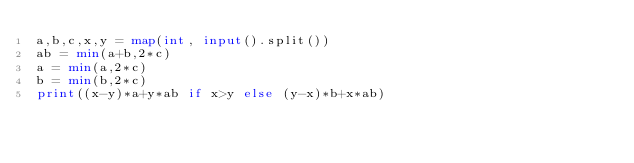<code> <loc_0><loc_0><loc_500><loc_500><_Python_>a,b,c,x,y = map(int, input().split())
ab = min(a+b,2*c)
a = min(a,2*c)
b = min(b,2*c)
print((x-y)*a+y*ab if x>y else (y-x)*b+x*ab)</code> 